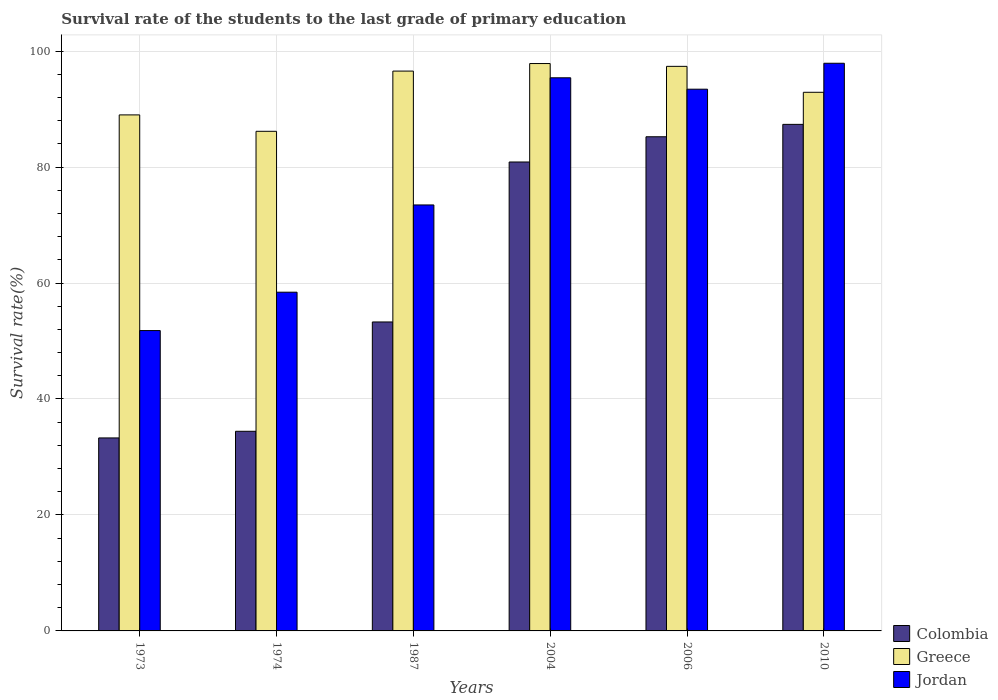Are the number of bars per tick equal to the number of legend labels?
Make the answer very short. Yes. Are the number of bars on each tick of the X-axis equal?
Make the answer very short. Yes. What is the label of the 4th group of bars from the left?
Your response must be concise. 2004. In how many cases, is the number of bars for a given year not equal to the number of legend labels?
Offer a terse response. 0. What is the survival rate of the students in Colombia in 2006?
Offer a very short reply. 85.22. Across all years, what is the maximum survival rate of the students in Greece?
Give a very brief answer. 97.85. Across all years, what is the minimum survival rate of the students in Greece?
Make the answer very short. 86.16. In which year was the survival rate of the students in Colombia maximum?
Offer a very short reply. 2010. In which year was the survival rate of the students in Jordan minimum?
Provide a short and direct response. 1973. What is the total survival rate of the students in Jordan in the graph?
Ensure brevity in your answer.  470.4. What is the difference between the survival rate of the students in Greece in 1974 and that in 2006?
Offer a terse response. -11.2. What is the difference between the survival rate of the students in Jordan in 1973 and the survival rate of the students in Colombia in 1987?
Your answer should be very brief. -1.49. What is the average survival rate of the students in Colombia per year?
Ensure brevity in your answer.  62.41. In the year 1973, what is the difference between the survival rate of the students in Colombia and survival rate of the students in Greece?
Ensure brevity in your answer.  -55.71. In how many years, is the survival rate of the students in Colombia greater than 36 %?
Your answer should be very brief. 4. What is the ratio of the survival rate of the students in Colombia in 1974 to that in 1987?
Ensure brevity in your answer.  0.65. Is the survival rate of the students in Colombia in 2006 less than that in 2010?
Ensure brevity in your answer.  Yes. What is the difference between the highest and the second highest survival rate of the students in Jordan?
Make the answer very short. 2.51. What is the difference between the highest and the lowest survival rate of the students in Greece?
Ensure brevity in your answer.  11.69. Is the sum of the survival rate of the students in Colombia in 1974 and 2006 greater than the maximum survival rate of the students in Greece across all years?
Provide a short and direct response. Yes. What does the 3rd bar from the left in 1973 represents?
Provide a short and direct response. Jordan. What does the 1st bar from the right in 2004 represents?
Offer a very short reply. Jordan. Is it the case that in every year, the sum of the survival rate of the students in Greece and survival rate of the students in Jordan is greater than the survival rate of the students in Colombia?
Your answer should be compact. Yes. How many bars are there?
Offer a very short reply. 18. What is the difference between two consecutive major ticks on the Y-axis?
Provide a short and direct response. 20. Does the graph contain grids?
Offer a terse response. Yes. Where does the legend appear in the graph?
Make the answer very short. Bottom right. How many legend labels are there?
Your answer should be very brief. 3. How are the legend labels stacked?
Give a very brief answer. Vertical. What is the title of the graph?
Give a very brief answer. Survival rate of the students to the last grade of primary education. Does "Botswana" appear as one of the legend labels in the graph?
Keep it short and to the point. No. What is the label or title of the X-axis?
Give a very brief answer. Years. What is the label or title of the Y-axis?
Your response must be concise. Survival rate(%). What is the Survival rate(%) in Colombia in 1973?
Make the answer very short. 33.28. What is the Survival rate(%) of Greece in 1973?
Your answer should be very brief. 88.99. What is the Survival rate(%) of Jordan in 1973?
Your answer should be very brief. 51.8. What is the Survival rate(%) in Colombia in 1974?
Offer a very short reply. 34.43. What is the Survival rate(%) in Greece in 1974?
Give a very brief answer. 86.16. What is the Survival rate(%) of Jordan in 1974?
Ensure brevity in your answer.  58.42. What is the Survival rate(%) in Colombia in 1987?
Ensure brevity in your answer.  53.28. What is the Survival rate(%) of Greece in 1987?
Offer a very short reply. 96.55. What is the Survival rate(%) in Jordan in 1987?
Make the answer very short. 73.46. What is the Survival rate(%) in Colombia in 2004?
Make the answer very short. 80.87. What is the Survival rate(%) in Greece in 2004?
Keep it short and to the point. 97.85. What is the Survival rate(%) of Jordan in 2004?
Your answer should be very brief. 95.39. What is the Survival rate(%) of Colombia in 2006?
Your answer should be compact. 85.22. What is the Survival rate(%) in Greece in 2006?
Provide a succinct answer. 97.36. What is the Survival rate(%) of Jordan in 2006?
Make the answer very short. 93.43. What is the Survival rate(%) of Colombia in 2010?
Provide a succinct answer. 87.36. What is the Survival rate(%) of Greece in 2010?
Ensure brevity in your answer.  92.89. What is the Survival rate(%) in Jordan in 2010?
Provide a short and direct response. 97.9. Across all years, what is the maximum Survival rate(%) in Colombia?
Provide a short and direct response. 87.36. Across all years, what is the maximum Survival rate(%) of Greece?
Provide a short and direct response. 97.85. Across all years, what is the maximum Survival rate(%) in Jordan?
Ensure brevity in your answer.  97.9. Across all years, what is the minimum Survival rate(%) of Colombia?
Your answer should be very brief. 33.28. Across all years, what is the minimum Survival rate(%) of Greece?
Provide a succinct answer. 86.16. Across all years, what is the minimum Survival rate(%) in Jordan?
Ensure brevity in your answer.  51.8. What is the total Survival rate(%) in Colombia in the graph?
Offer a terse response. 374.45. What is the total Survival rate(%) of Greece in the graph?
Your response must be concise. 559.81. What is the total Survival rate(%) of Jordan in the graph?
Keep it short and to the point. 470.4. What is the difference between the Survival rate(%) in Colombia in 1973 and that in 1974?
Provide a succinct answer. -1.14. What is the difference between the Survival rate(%) of Greece in 1973 and that in 1974?
Offer a terse response. 2.83. What is the difference between the Survival rate(%) in Jordan in 1973 and that in 1974?
Your answer should be compact. -6.62. What is the difference between the Survival rate(%) in Colombia in 1973 and that in 1987?
Offer a terse response. -20. What is the difference between the Survival rate(%) of Greece in 1973 and that in 1987?
Offer a terse response. -7.56. What is the difference between the Survival rate(%) of Jordan in 1973 and that in 1987?
Give a very brief answer. -21.67. What is the difference between the Survival rate(%) in Colombia in 1973 and that in 2004?
Provide a succinct answer. -47.59. What is the difference between the Survival rate(%) of Greece in 1973 and that in 2004?
Make the answer very short. -8.86. What is the difference between the Survival rate(%) of Jordan in 1973 and that in 2004?
Offer a very short reply. -43.59. What is the difference between the Survival rate(%) in Colombia in 1973 and that in 2006?
Your answer should be compact. -51.94. What is the difference between the Survival rate(%) of Greece in 1973 and that in 2006?
Ensure brevity in your answer.  -8.37. What is the difference between the Survival rate(%) of Jordan in 1973 and that in 2006?
Offer a very short reply. -41.63. What is the difference between the Survival rate(%) in Colombia in 1973 and that in 2010?
Your answer should be very brief. -54.08. What is the difference between the Survival rate(%) of Greece in 1973 and that in 2010?
Give a very brief answer. -3.9. What is the difference between the Survival rate(%) of Jordan in 1973 and that in 2010?
Ensure brevity in your answer.  -46.1. What is the difference between the Survival rate(%) in Colombia in 1974 and that in 1987?
Keep it short and to the point. -18.85. What is the difference between the Survival rate(%) in Greece in 1974 and that in 1987?
Give a very brief answer. -10.39. What is the difference between the Survival rate(%) in Jordan in 1974 and that in 1987?
Offer a terse response. -15.05. What is the difference between the Survival rate(%) of Colombia in 1974 and that in 2004?
Give a very brief answer. -46.44. What is the difference between the Survival rate(%) of Greece in 1974 and that in 2004?
Offer a terse response. -11.69. What is the difference between the Survival rate(%) of Jordan in 1974 and that in 2004?
Your response must be concise. -36.97. What is the difference between the Survival rate(%) of Colombia in 1974 and that in 2006?
Ensure brevity in your answer.  -50.79. What is the difference between the Survival rate(%) of Greece in 1974 and that in 2006?
Your response must be concise. -11.2. What is the difference between the Survival rate(%) of Jordan in 1974 and that in 2006?
Ensure brevity in your answer.  -35.01. What is the difference between the Survival rate(%) of Colombia in 1974 and that in 2010?
Give a very brief answer. -52.93. What is the difference between the Survival rate(%) of Greece in 1974 and that in 2010?
Offer a very short reply. -6.73. What is the difference between the Survival rate(%) of Jordan in 1974 and that in 2010?
Your answer should be compact. -39.48. What is the difference between the Survival rate(%) of Colombia in 1987 and that in 2004?
Offer a terse response. -27.59. What is the difference between the Survival rate(%) in Greece in 1987 and that in 2004?
Your response must be concise. -1.3. What is the difference between the Survival rate(%) in Jordan in 1987 and that in 2004?
Offer a very short reply. -21.93. What is the difference between the Survival rate(%) in Colombia in 1987 and that in 2006?
Ensure brevity in your answer.  -31.94. What is the difference between the Survival rate(%) in Greece in 1987 and that in 2006?
Your response must be concise. -0.82. What is the difference between the Survival rate(%) of Jordan in 1987 and that in 2006?
Offer a terse response. -19.96. What is the difference between the Survival rate(%) in Colombia in 1987 and that in 2010?
Give a very brief answer. -34.08. What is the difference between the Survival rate(%) in Greece in 1987 and that in 2010?
Offer a terse response. 3.66. What is the difference between the Survival rate(%) in Jordan in 1987 and that in 2010?
Your answer should be compact. -24.44. What is the difference between the Survival rate(%) of Colombia in 2004 and that in 2006?
Give a very brief answer. -4.35. What is the difference between the Survival rate(%) of Greece in 2004 and that in 2006?
Offer a terse response. 0.49. What is the difference between the Survival rate(%) of Jordan in 2004 and that in 2006?
Your response must be concise. 1.97. What is the difference between the Survival rate(%) in Colombia in 2004 and that in 2010?
Your answer should be very brief. -6.49. What is the difference between the Survival rate(%) in Greece in 2004 and that in 2010?
Your response must be concise. 4.96. What is the difference between the Survival rate(%) of Jordan in 2004 and that in 2010?
Ensure brevity in your answer.  -2.51. What is the difference between the Survival rate(%) in Colombia in 2006 and that in 2010?
Give a very brief answer. -2.14. What is the difference between the Survival rate(%) in Greece in 2006 and that in 2010?
Provide a short and direct response. 4.47. What is the difference between the Survival rate(%) of Jordan in 2006 and that in 2010?
Make the answer very short. -4.47. What is the difference between the Survival rate(%) in Colombia in 1973 and the Survival rate(%) in Greece in 1974?
Offer a very short reply. -52.88. What is the difference between the Survival rate(%) of Colombia in 1973 and the Survival rate(%) of Jordan in 1974?
Your answer should be compact. -25.13. What is the difference between the Survival rate(%) in Greece in 1973 and the Survival rate(%) in Jordan in 1974?
Make the answer very short. 30.57. What is the difference between the Survival rate(%) of Colombia in 1973 and the Survival rate(%) of Greece in 1987?
Make the answer very short. -63.26. What is the difference between the Survival rate(%) of Colombia in 1973 and the Survival rate(%) of Jordan in 1987?
Give a very brief answer. -40.18. What is the difference between the Survival rate(%) in Greece in 1973 and the Survival rate(%) in Jordan in 1987?
Offer a very short reply. 15.53. What is the difference between the Survival rate(%) in Colombia in 1973 and the Survival rate(%) in Greece in 2004?
Your response must be concise. -64.57. What is the difference between the Survival rate(%) of Colombia in 1973 and the Survival rate(%) of Jordan in 2004?
Make the answer very short. -62.11. What is the difference between the Survival rate(%) of Greece in 1973 and the Survival rate(%) of Jordan in 2004?
Make the answer very short. -6.4. What is the difference between the Survival rate(%) in Colombia in 1973 and the Survival rate(%) in Greece in 2006?
Your answer should be compact. -64.08. What is the difference between the Survival rate(%) of Colombia in 1973 and the Survival rate(%) of Jordan in 2006?
Your response must be concise. -60.14. What is the difference between the Survival rate(%) of Greece in 1973 and the Survival rate(%) of Jordan in 2006?
Provide a succinct answer. -4.43. What is the difference between the Survival rate(%) in Colombia in 1973 and the Survival rate(%) in Greece in 2010?
Provide a succinct answer. -59.61. What is the difference between the Survival rate(%) in Colombia in 1973 and the Survival rate(%) in Jordan in 2010?
Make the answer very short. -64.61. What is the difference between the Survival rate(%) in Greece in 1973 and the Survival rate(%) in Jordan in 2010?
Provide a short and direct response. -8.91. What is the difference between the Survival rate(%) in Colombia in 1974 and the Survival rate(%) in Greece in 1987?
Provide a succinct answer. -62.12. What is the difference between the Survival rate(%) of Colombia in 1974 and the Survival rate(%) of Jordan in 1987?
Give a very brief answer. -39.03. What is the difference between the Survival rate(%) in Greece in 1974 and the Survival rate(%) in Jordan in 1987?
Your response must be concise. 12.7. What is the difference between the Survival rate(%) in Colombia in 1974 and the Survival rate(%) in Greece in 2004?
Keep it short and to the point. -63.42. What is the difference between the Survival rate(%) of Colombia in 1974 and the Survival rate(%) of Jordan in 2004?
Make the answer very short. -60.96. What is the difference between the Survival rate(%) of Greece in 1974 and the Survival rate(%) of Jordan in 2004?
Make the answer very short. -9.23. What is the difference between the Survival rate(%) of Colombia in 1974 and the Survival rate(%) of Greece in 2006?
Your response must be concise. -62.94. What is the difference between the Survival rate(%) in Colombia in 1974 and the Survival rate(%) in Jordan in 2006?
Ensure brevity in your answer.  -59. What is the difference between the Survival rate(%) in Greece in 1974 and the Survival rate(%) in Jordan in 2006?
Keep it short and to the point. -7.26. What is the difference between the Survival rate(%) in Colombia in 1974 and the Survival rate(%) in Greece in 2010?
Ensure brevity in your answer.  -58.46. What is the difference between the Survival rate(%) of Colombia in 1974 and the Survival rate(%) of Jordan in 2010?
Make the answer very short. -63.47. What is the difference between the Survival rate(%) of Greece in 1974 and the Survival rate(%) of Jordan in 2010?
Offer a terse response. -11.74. What is the difference between the Survival rate(%) of Colombia in 1987 and the Survival rate(%) of Greece in 2004?
Provide a short and direct response. -44.57. What is the difference between the Survival rate(%) in Colombia in 1987 and the Survival rate(%) in Jordan in 2004?
Offer a very short reply. -42.11. What is the difference between the Survival rate(%) of Greece in 1987 and the Survival rate(%) of Jordan in 2004?
Make the answer very short. 1.16. What is the difference between the Survival rate(%) in Colombia in 1987 and the Survival rate(%) in Greece in 2006?
Your answer should be compact. -44.08. What is the difference between the Survival rate(%) in Colombia in 1987 and the Survival rate(%) in Jordan in 2006?
Make the answer very short. -40.14. What is the difference between the Survival rate(%) of Greece in 1987 and the Survival rate(%) of Jordan in 2006?
Make the answer very short. 3.12. What is the difference between the Survival rate(%) in Colombia in 1987 and the Survival rate(%) in Greece in 2010?
Provide a short and direct response. -39.61. What is the difference between the Survival rate(%) of Colombia in 1987 and the Survival rate(%) of Jordan in 2010?
Make the answer very short. -44.62. What is the difference between the Survival rate(%) in Greece in 1987 and the Survival rate(%) in Jordan in 2010?
Provide a succinct answer. -1.35. What is the difference between the Survival rate(%) of Colombia in 2004 and the Survival rate(%) of Greece in 2006?
Provide a succinct answer. -16.49. What is the difference between the Survival rate(%) in Colombia in 2004 and the Survival rate(%) in Jordan in 2006?
Offer a very short reply. -12.55. What is the difference between the Survival rate(%) in Greece in 2004 and the Survival rate(%) in Jordan in 2006?
Keep it short and to the point. 4.43. What is the difference between the Survival rate(%) of Colombia in 2004 and the Survival rate(%) of Greece in 2010?
Make the answer very short. -12.02. What is the difference between the Survival rate(%) of Colombia in 2004 and the Survival rate(%) of Jordan in 2010?
Offer a very short reply. -17.03. What is the difference between the Survival rate(%) of Greece in 2004 and the Survival rate(%) of Jordan in 2010?
Make the answer very short. -0.05. What is the difference between the Survival rate(%) of Colombia in 2006 and the Survival rate(%) of Greece in 2010?
Provide a succinct answer. -7.67. What is the difference between the Survival rate(%) in Colombia in 2006 and the Survival rate(%) in Jordan in 2010?
Make the answer very short. -12.68. What is the difference between the Survival rate(%) in Greece in 2006 and the Survival rate(%) in Jordan in 2010?
Provide a succinct answer. -0.53. What is the average Survival rate(%) of Colombia per year?
Offer a very short reply. 62.41. What is the average Survival rate(%) of Greece per year?
Ensure brevity in your answer.  93.3. What is the average Survival rate(%) in Jordan per year?
Make the answer very short. 78.4. In the year 1973, what is the difference between the Survival rate(%) in Colombia and Survival rate(%) in Greece?
Give a very brief answer. -55.71. In the year 1973, what is the difference between the Survival rate(%) in Colombia and Survival rate(%) in Jordan?
Give a very brief answer. -18.51. In the year 1973, what is the difference between the Survival rate(%) in Greece and Survival rate(%) in Jordan?
Ensure brevity in your answer.  37.19. In the year 1974, what is the difference between the Survival rate(%) in Colombia and Survival rate(%) in Greece?
Your response must be concise. -51.73. In the year 1974, what is the difference between the Survival rate(%) in Colombia and Survival rate(%) in Jordan?
Keep it short and to the point. -23.99. In the year 1974, what is the difference between the Survival rate(%) in Greece and Survival rate(%) in Jordan?
Make the answer very short. 27.75. In the year 1987, what is the difference between the Survival rate(%) of Colombia and Survival rate(%) of Greece?
Provide a succinct answer. -43.27. In the year 1987, what is the difference between the Survival rate(%) in Colombia and Survival rate(%) in Jordan?
Ensure brevity in your answer.  -20.18. In the year 1987, what is the difference between the Survival rate(%) of Greece and Survival rate(%) of Jordan?
Provide a short and direct response. 23.08. In the year 2004, what is the difference between the Survival rate(%) of Colombia and Survival rate(%) of Greece?
Offer a terse response. -16.98. In the year 2004, what is the difference between the Survival rate(%) of Colombia and Survival rate(%) of Jordan?
Offer a terse response. -14.52. In the year 2004, what is the difference between the Survival rate(%) in Greece and Survival rate(%) in Jordan?
Offer a terse response. 2.46. In the year 2006, what is the difference between the Survival rate(%) of Colombia and Survival rate(%) of Greece?
Provide a short and direct response. -12.14. In the year 2006, what is the difference between the Survival rate(%) of Colombia and Survival rate(%) of Jordan?
Provide a succinct answer. -8.2. In the year 2006, what is the difference between the Survival rate(%) in Greece and Survival rate(%) in Jordan?
Your answer should be compact. 3.94. In the year 2010, what is the difference between the Survival rate(%) of Colombia and Survival rate(%) of Greece?
Ensure brevity in your answer.  -5.53. In the year 2010, what is the difference between the Survival rate(%) of Colombia and Survival rate(%) of Jordan?
Give a very brief answer. -10.54. In the year 2010, what is the difference between the Survival rate(%) of Greece and Survival rate(%) of Jordan?
Provide a short and direct response. -5.01. What is the ratio of the Survival rate(%) in Colombia in 1973 to that in 1974?
Keep it short and to the point. 0.97. What is the ratio of the Survival rate(%) in Greece in 1973 to that in 1974?
Provide a short and direct response. 1.03. What is the ratio of the Survival rate(%) in Jordan in 1973 to that in 1974?
Give a very brief answer. 0.89. What is the ratio of the Survival rate(%) of Colombia in 1973 to that in 1987?
Offer a terse response. 0.62. What is the ratio of the Survival rate(%) of Greece in 1973 to that in 1987?
Make the answer very short. 0.92. What is the ratio of the Survival rate(%) in Jordan in 1973 to that in 1987?
Provide a succinct answer. 0.71. What is the ratio of the Survival rate(%) in Colombia in 1973 to that in 2004?
Make the answer very short. 0.41. What is the ratio of the Survival rate(%) of Greece in 1973 to that in 2004?
Your response must be concise. 0.91. What is the ratio of the Survival rate(%) in Jordan in 1973 to that in 2004?
Your answer should be compact. 0.54. What is the ratio of the Survival rate(%) of Colombia in 1973 to that in 2006?
Your answer should be compact. 0.39. What is the ratio of the Survival rate(%) of Greece in 1973 to that in 2006?
Offer a terse response. 0.91. What is the ratio of the Survival rate(%) of Jordan in 1973 to that in 2006?
Ensure brevity in your answer.  0.55. What is the ratio of the Survival rate(%) in Colombia in 1973 to that in 2010?
Offer a very short reply. 0.38. What is the ratio of the Survival rate(%) of Greece in 1973 to that in 2010?
Keep it short and to the point. 0.96. What is the ratio of the Survival rate(%) in Jordan in 1973 to that in 2010?
Provide a short and direct response. 0.53. What is the ratio of the Survival rate(%) of Colombia in 1974 to that in 1987?
Your answer should be compact. 0.65. What is the ratio of the Survival rate(%) in Greece in 1974 to that in 1987?
Offer a terse response. 0.89. What is the ratio of the Survival rate(%) of Jordan in 1974 to that in 1987?
Your response must be concise. 0.8. What is the ratio of the Survival rate(%) of Colombia in 1974 to that in 2004?
Keep it short and to the point. 0.43. What is the ratio of the Survival rate(%) in Greece in 1974 to that in 2004?
Make the answer very short. 0.88. What is the ratio of the Survival rate(%) of Jordan in 1974 to that in 2004?
Give a very brief answer. 0.61. What is the ratio of the Survival rate(%) of Colombia in 1974 to that in 2006?
Give a very brief answer. 0.4. What is the ratio of the Survival rate(%) in Greece in 1974 to that in 2006?
Provide a succinct answer. 0.88. What is the ratio of the Survival rate(%) of Jordan in 1974 to that in 2006?
Your response must be concise. 0.63. What is the ratio of the Survival rate(%) of Colombia in 1974 to that in 2010?
Your answer should be very brief. 0.39. What is the ratio of the Survival rate(%) of Greece in 1974 to that in 2010?
Your answer should be compact. 0.93. What is the ratio of the Survival rate(%) of Jordan in 1974 to that in 2010?
Your answer should be compact. 0.6. What is the ratio of the Survival rate(%) of Colombia in 1987 to that in 2004?
Your answer should be compact. 0.66. What is the ratio of the Survival rate(%) of Greece in 1987 to that in 2004?
Offer a terse response. 0.99. What is the ratio of the Survival rate(%) in Jordan in 1987 to that in 2004?
Ensure brevity in your answer.  0.77. What is the ratio of the Survival rate(%) of Colombia in 1987 to that in 2006?
Give a very brief answer. 0.63. What is the ratio of the Survival rate(%) of Greece in 1987 to that in 2006?
Keep it short and to the point. 0.99. What is the ratio of the Survival rate(%) in Jordan in 1987 to that in 2006?
Your answer should be compact. 0.79. What is the ratio of the Survival rate(%) of Colombia in 1987 to that in 2010?
Your response must be concise. 0.61. What is the ratio of the Survival rate(%) in Greece in 1987 to that in 2010?
Your answer should be compact. 1.04. What is the ratio of the Survival rate(%) of Jordan in 1987 to that in 2010?
Your response must be concise. 0.75. What is the ratio of the Survival rate(%) in Colombia in 2004 to that in 2006?
Give a very brief answer. 0.95. What is the ratio of the Survival rate(%) of Colombia in 2004 to that in 2010?
Offer a very short reply. 0.93. What is the ratio of the Survival rate(%) in Greece in 2004 to that in 2010?
Your response must be concise. 1.05. What is the ratio of the Survival rate(%) of Jordan in 2004 to that in 2010?
Your answer should be compact. 0.97. What is the ratio of the Survival rate(%) in Colombia in 2006 to that in 2010?
Your answer should be compact. 0.98. What is the ratio of the Survival rate(%) in Greece in 2006 to that in 2010?
Offer a terse response. 1.05. What is the ratio of the Survival rate(%) in Jordan in 2006 to that in 2010?
Your answer should be very brief. 0.95. What is the difference between the highest and the second highest Survival rate(%) in Colombia?
Keep it short and to the point. 2.14. What is the difference between the highest and the second highest Survival rate(%) in Greece?
Make the answer very short. 0.49. What is the difference between the highest and the second highest Survival rate(%) of Jordan?
Provide a succinct answer. 2.51. What is the difference between the highest and the lowest Survival rate(%) in Colombia?
Offer a very short reply. 54.08. What is the difference between the highest and the lowest Survival rate(%) in Greece?
Make the answer very short. 11.69. What is the difference between the highest and the lowest Survival rate(%) in Jordan?
Keep it short and to the point. 46.1. 